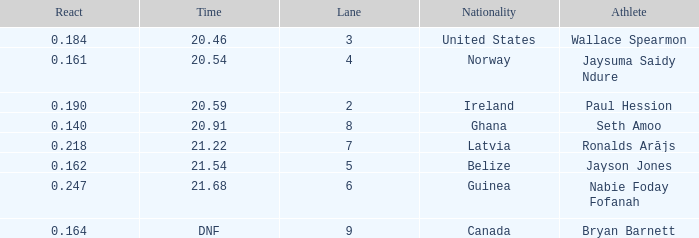What is the lowest lane when react is more than 0.164 and the nationality is guinea? 6.0. 